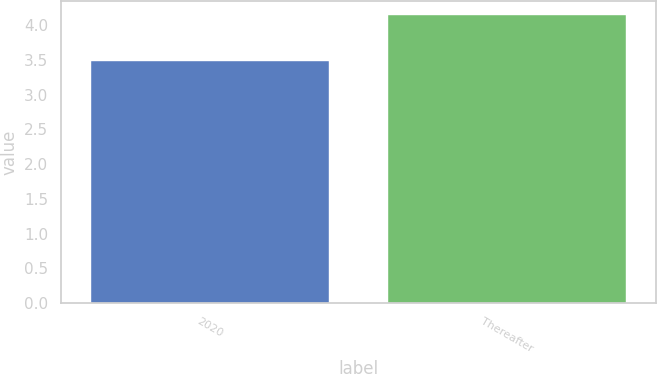<chart> <loc_0><loc_0><loc_500><loc_500><bar_chart><fcel>2020<fcel>Thereafter<nl><fcel>3.49<fcel>4.14<nl></chart> 